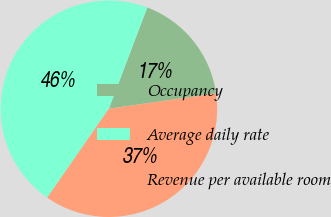Convert chart. <chart><loc_0><loc_0><loc_500><loc_500><pie_chart><fcel>Occupancy<fcel>Average daily rate<fcel>Revenue per available room<nl><fcel>16.98%<fcel>46.12%<fcel>36.9%<nl></chart> 